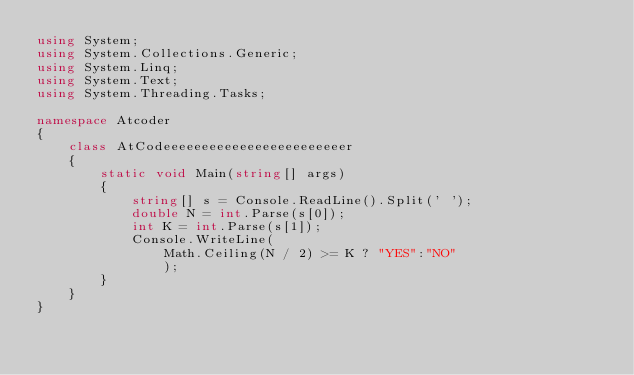<code> <loc_0><loc_0><loc_500><loc_500><_C#_>using System;
using System.Collections.Generic;
using System.Linq;
using System.Text;
using System.Threading.Tasks;

namespace Atcoder
{
    class AtCodeeeeeeeeeeeeeeeeeeeeeeeer
    {
        static void Main(string[] args)
        {
            string[] s = Console.ReadLine().Split(' ');
            double N = int.Parse(s[0]);
            int K = int.Parse(s[1]);
            Console.WriteLine(
                Math.Ceiling(N / 2) >= K ? "YES":"NO"
                );
        }
    }
}
</code> 